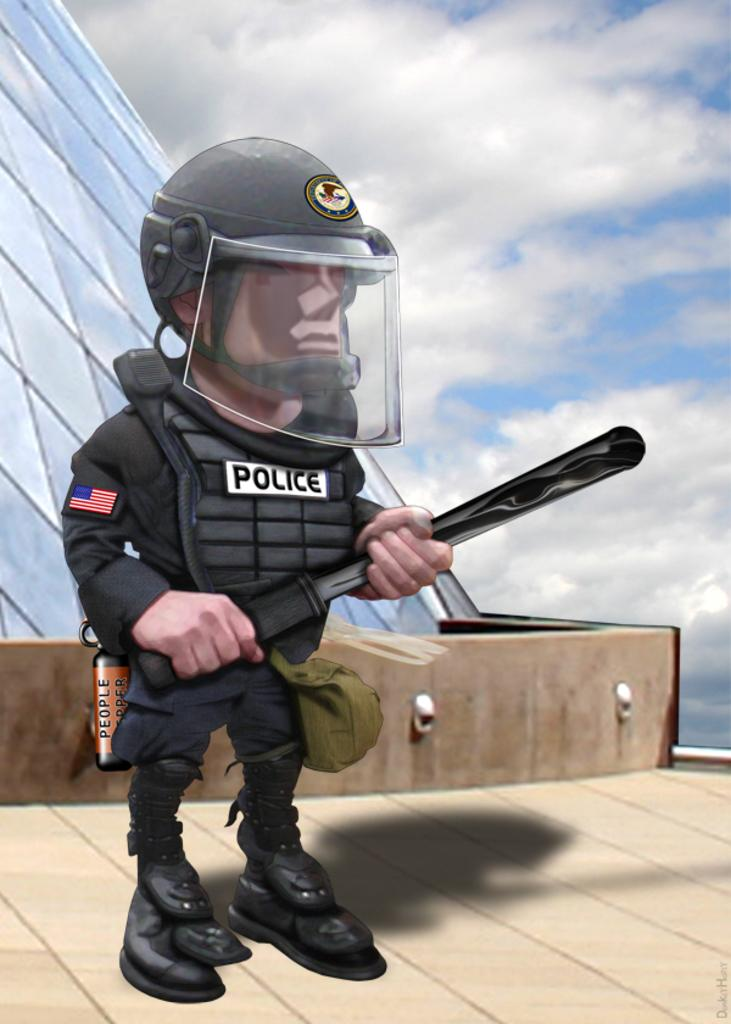What type of picture is the image? The image is an animated picture. What can be seen in the image? There is a man standing in the image, and he is holding an object. What is the man wearing on his head? The man is wearing a helmet. What material is visible in the image? There is glass visible in the image. What architectural feature is present in the image? There is a wall in the image. What can be seen in the background of the image? The sky with clouds is visible in the background of the image. What type of harmony is the man playing on in the image? There is no musical instrument or harmony present in the image; the man is holding an object, but its purpose is not specified. 